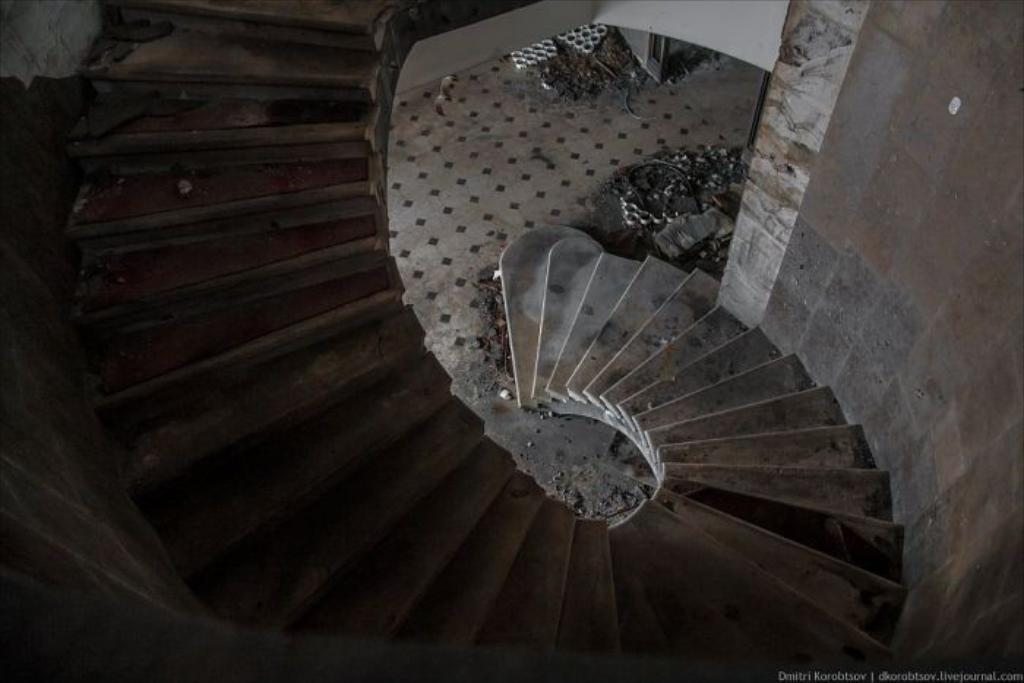What is the main subject in the center of the image? There is a wall and a staircase in the center of the image. Can you describe the staircase in the image? The staircase is located in the center of the image. What other objects can be seen in the center of the image? There are a few other objects in the center of the image. What type of powder is being used to settle the argument in the image? There is no argument or powder present in the image. What color is the vest worn by the person in the image? There is no person or vest present in the image. 